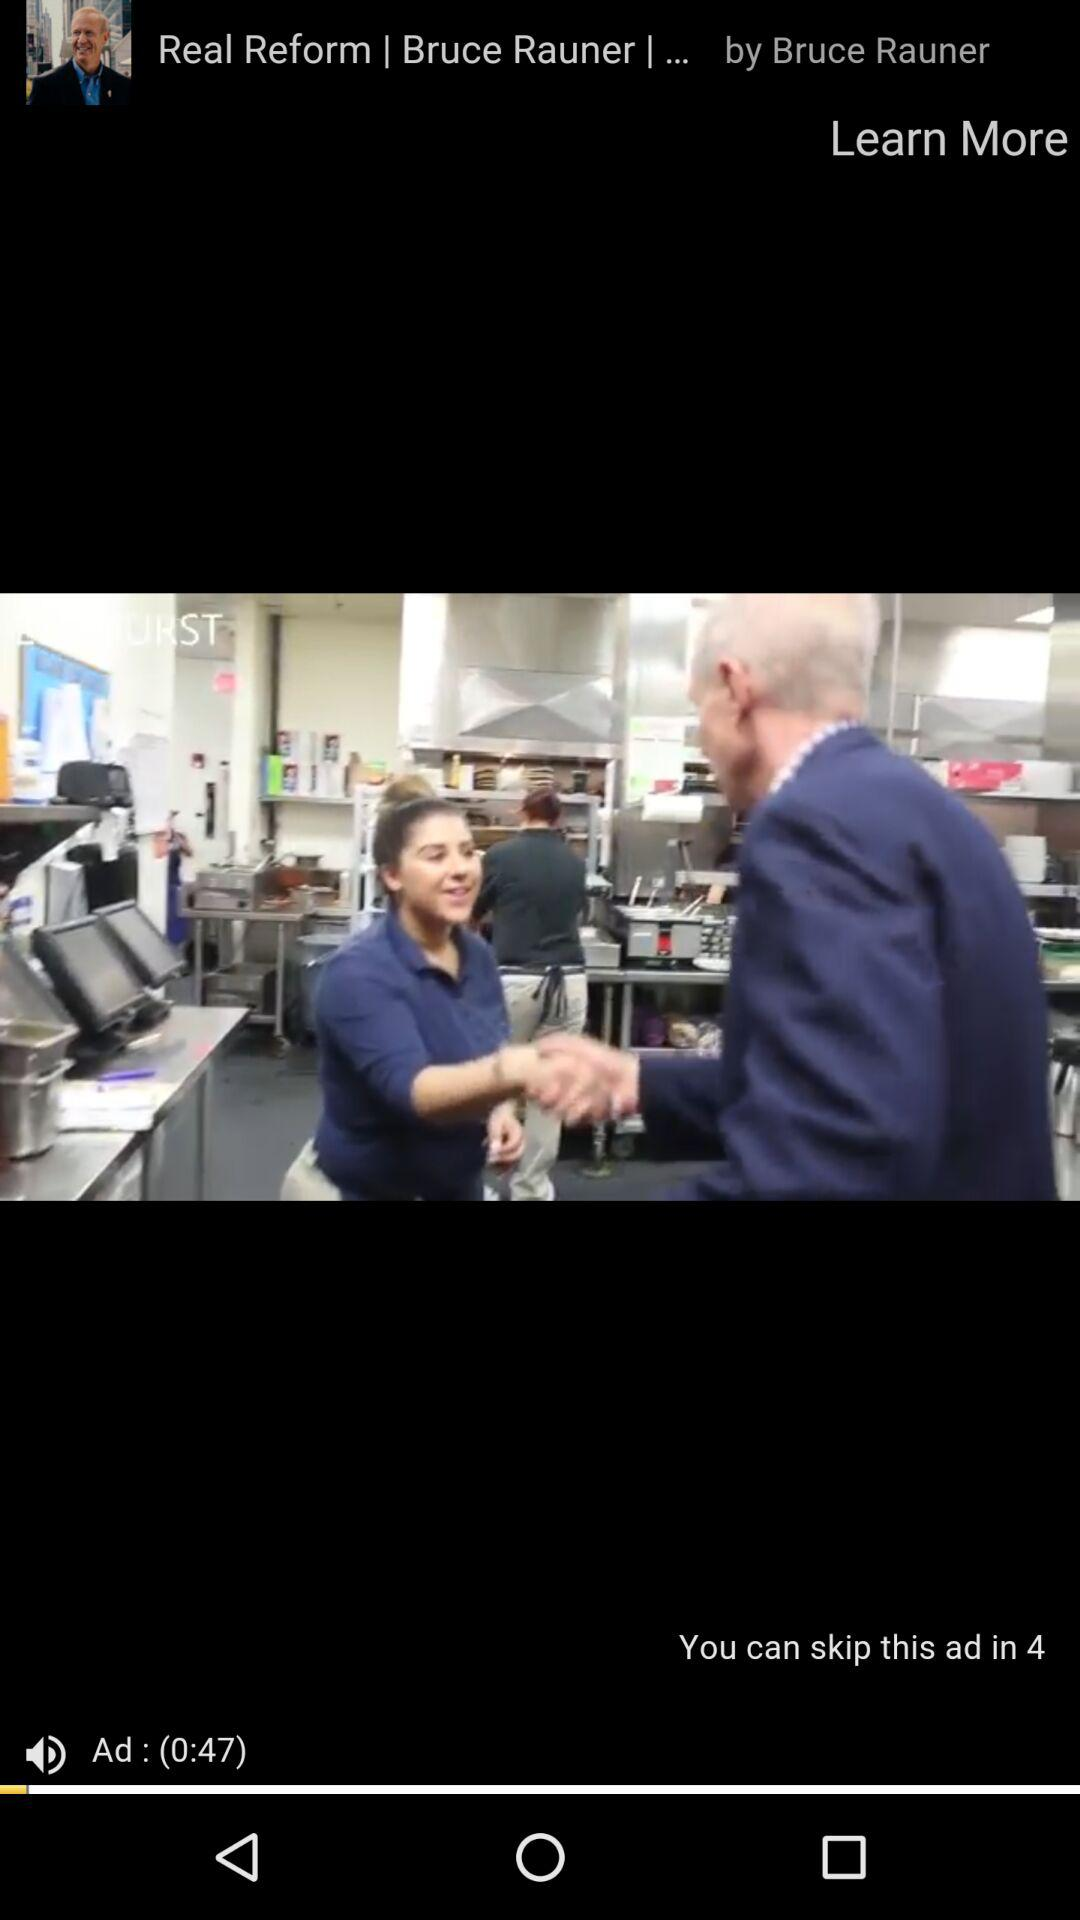How many seconds until the ad can be skipped?
Answer the question using a single word or phrase. 4 